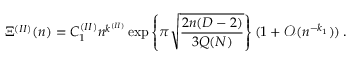Convert formula to latex. <formula><loc_0><loc_0><loc_500><loc_500>\Xi ^ { ( I I ) } ( n ) = C _ { 1 } ^ { ( I I ) } n ^ { k ^ { ( I I ) } } \exp \left \{ \pi \sqrt { \frac { 2 n ( D - 2 ) } { 3 Q ( N ) } } \right \} ( 1 + { \mathcal { O } } ( n ^ { - k _ { 1 } } ) ) \, .</formula> 